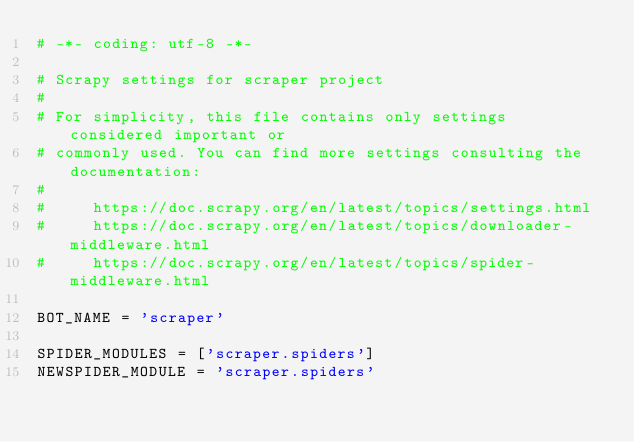Convert code to text. <code><loc_0><loc_0><loc_500><loc_500><_Python_># -*- coding: utf-8 -*-

# Scrapy settings for scraper project
#
# For simplicity, this file contains only settings considered important or
# commonly used. You can find more settings consulting the documentation:
#
#     https://doc.scrapy.org/en/latest/topics/settings.html
#     https://doc.scrapy.org/en/latest/topics/downloader-middleware.html
#     https://doc.scrapy.org/en/latest/topics/spider-middleware.html

BOT_NAME = 'scraper'

SPIDER_MODULES = ['scraper.spiders']
NEWSPIDER_MODULE = 'scraper.spiders'

</code> 